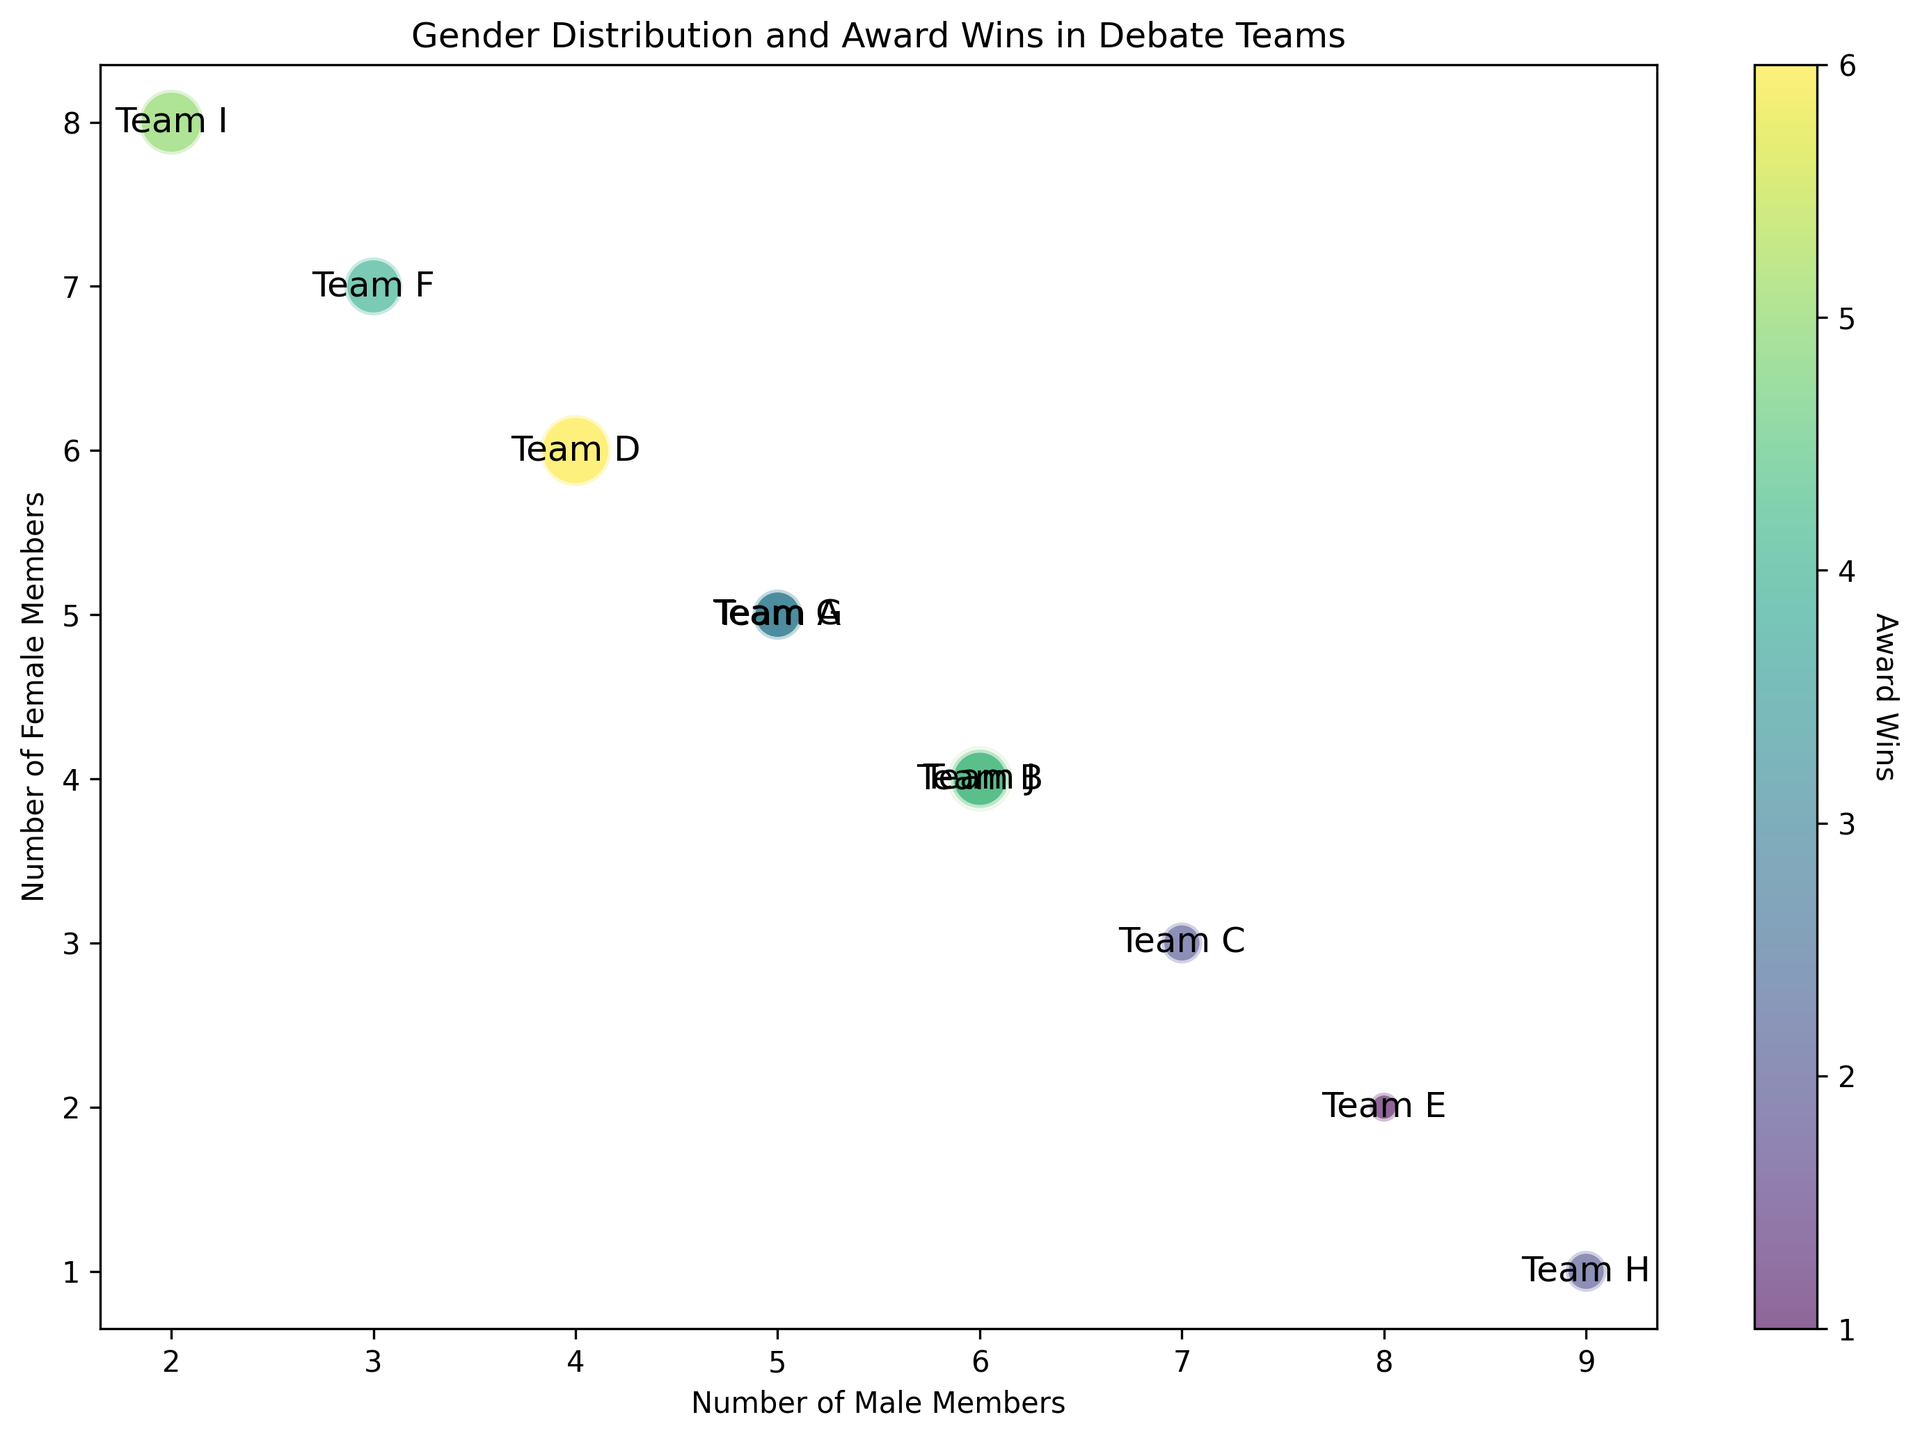How many teams have equal numbers of male and female members? Look for the teams whose male and female members are the same. Teams A and G both have 5 male and 5 female members.
Answer: 2 Which team has the highest number of award wins and what is their gender distribution? Identify the team with the largest bubble size. Team D has the highest number of award wins (6) and a gender distribution of 40-60 (4 male, 6 female).
Answer: Team D, 40-60 What is the total number of male members in the teams with 50-50 gender distribution? Sum the male members in teams with 50-50 distribution. Team A: 5 males, Team G: 5 males. Total = 5 + 5 = 10.
Answer: 10 Which team with a higher percentage of female members (greater than 50%) has the lowest award wins? Find teams with more females than males and compare their award wins. Team E (80-20) and Team B (60-40) have award wins of 1 and 5 respectively, both have higher males. Team F (30-70) has 4, Team I (20-80) has 5, and Team D (40-60) has 6. Therefore, Team F with a 30-70 distribution has 4 awards and is the lowest among higher female percentage.
Answer: Team F Compare the number of award wins of Team B and Team J. Team B has 5 award wins and Team J has 4 award wins.
Answer: Team B has more award wins Find the team with the maximum difference between the number of male and female members and state the difference. Calculate the differences for each team. Teams H has the highest difference (9 males and 1 female), the difference is 9 - 1 = 8.
Answer: Team H, 8 What is the average number of award wins across all teams? Sum the total number of award wins and divide by the number of teams (10). (3 + 5 + 2 + 6 + 1 + 4 + 3 + 2 + 5 + 4) = 35. Average = 35 / 10 = 3.5.
Answer: 3.5 Which teams have an equal number of total members (same bubble positions)? Teams A, G have equal male and female members (5 males, 5 females), they overlap in bubble positions.
Answer: Teams A and G Among the teams with equal gender distribution (50-50), which one has achieved more award wins? Compare award wins for teams with 50-50 distribution. Team A has 3 awards and Team G has 3 awards. They have achieved the same number.
Answer: Neither, both equal Which team has the least number of females and how many award wins do they have? Identify the team with the least female members. Team H has 1 female member and 2 award wins.
Answer: Team H, 2 